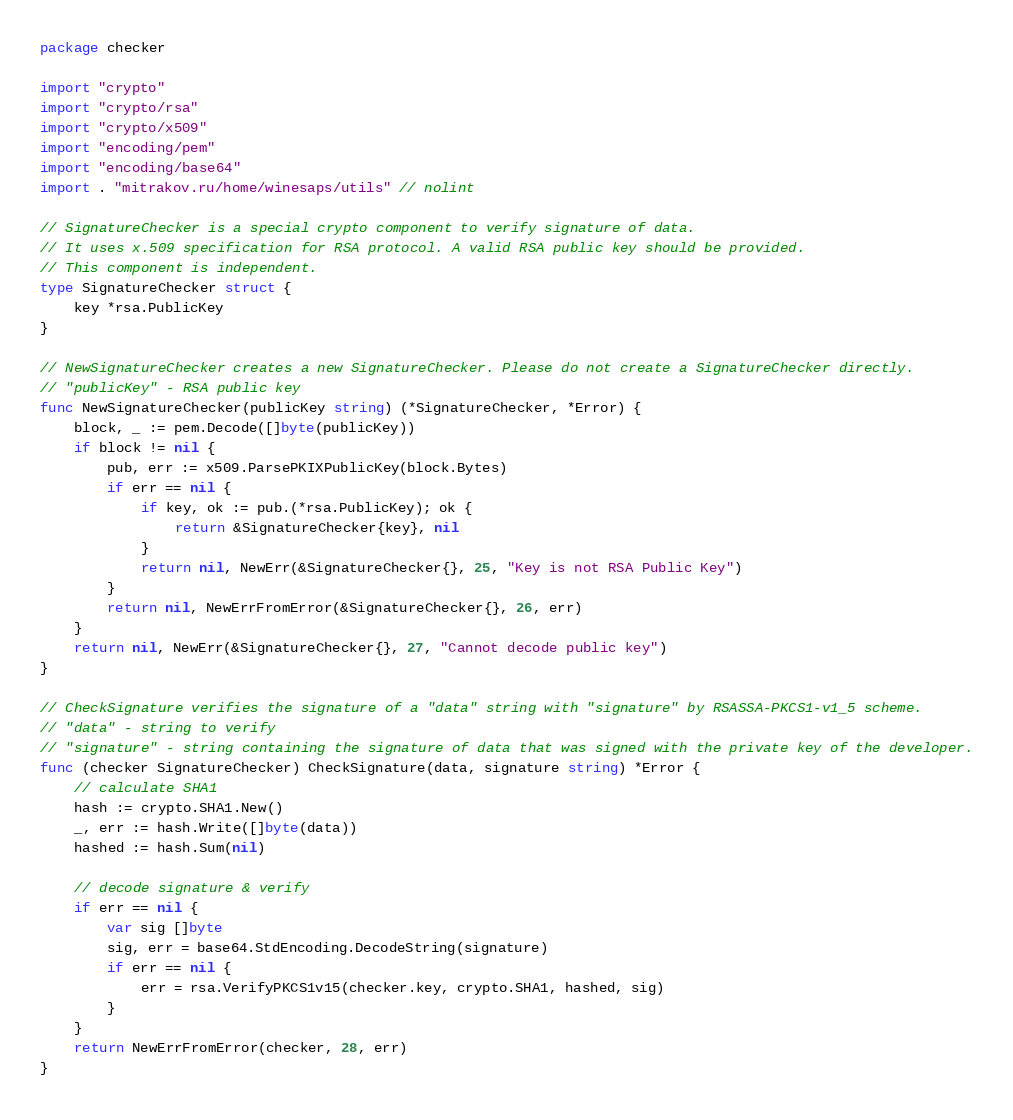Convert code to text. <code><loc_0><loc_0><loc_500><loc_500><_Go_>package checker

import "crypto"
import "crypto/rsa"
import "crypto/x509"
import "encoding/pem"
import "encoding/base64"
import . "mitrakov.ru/home/winesaps/utils" // nolint

// SignatureChecker is a special crypto component to verify signature of data.
// It uses x.509 specification for RSA protocol. A valid RSA public key should be provided.
// This component is independent.
type SignatureChecker struct {
    key *rsa.PublicKey
}

// NewSignatureChecker creates a new SignatureChecker. Please do not create a SignatureChecker directly.
// "publicKey" - RSA public key
func NewSignatureChecker(publicKey string) (*SignatureChecker, *Error) {
    block, _ := pem.Decode([]byte(publicKey))
    if block != nil {
        pub, err := x509.ParsePKIXPublicKey(block.Bytes)
        if err == nil {
            if key, ok := pub.(*rsa.PublicKey); ok {
                return &SignatureChecker{key}, nil
            }
            return nil, NewErr(&SignatureChecker{}, 25, "Key is not RSA Public Key")
        }
        return nil, NewErrFromError(&SignatureChecker{}, 26, err)
    }
    return nil, NewErr(&SignatureChecker{}, 27, "Cannot decode public key")
}

// CheckSignature verifies the signature of a "data" string with "signature" by RSASSA-PKCS1-v1_5 scheme.
// "data" - string to verify
// "signature" - string containing the signature of data that was signed with the private key of the developer.
func (checker SignatureChecker) CheckSignature(data, signature string) *Error {
    // calculate SHA1
    hash := crypto.SHA1.New()
    _, err := hash.Write([]byte(data))
    hashed := hash.Sum(nil)
    
    // decode signature & verify
    if err == nil {
        var sig []byte
        sig, err = base64.StdEncoding.DecodeString(signature)
        if err == nil {
            err = rsa.VerifyPKCS1v15(checker.key, crypto.SHA1, hashed, sig)
        }
    }
    return NewErrFromError(checker, 28, err)
}
</code> 